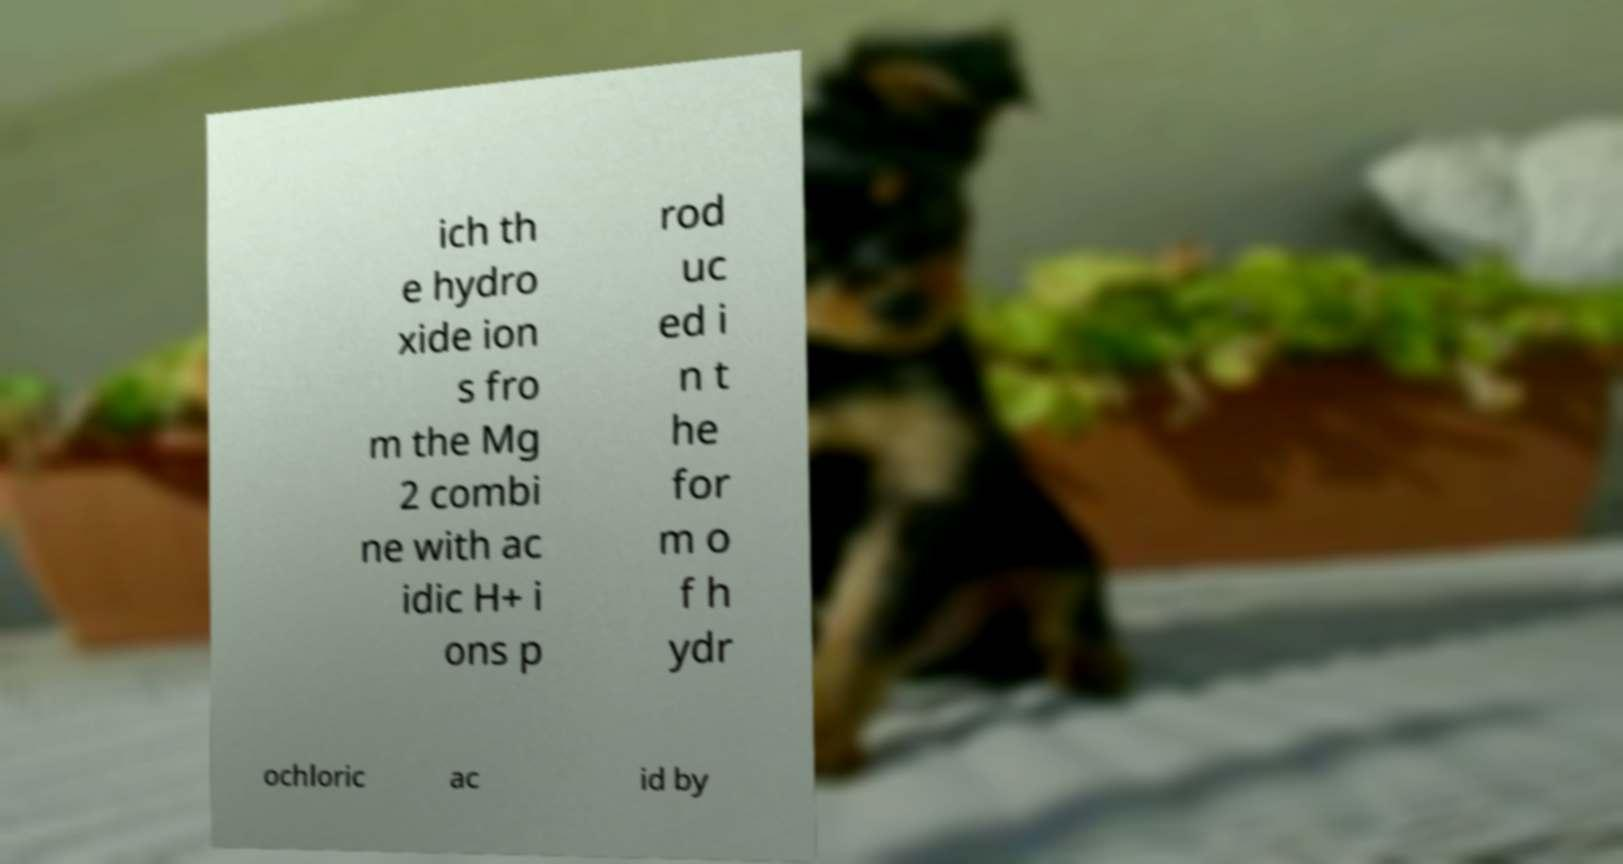For documentation purposes, I need the text within this image transcribed. Could you provide that? ich th e hydro xide ion s fro m the Mg 2 combi ne with ac idic H+ i ons p rod uc ed i n t he for m o f h ydr ochloric ac id by 